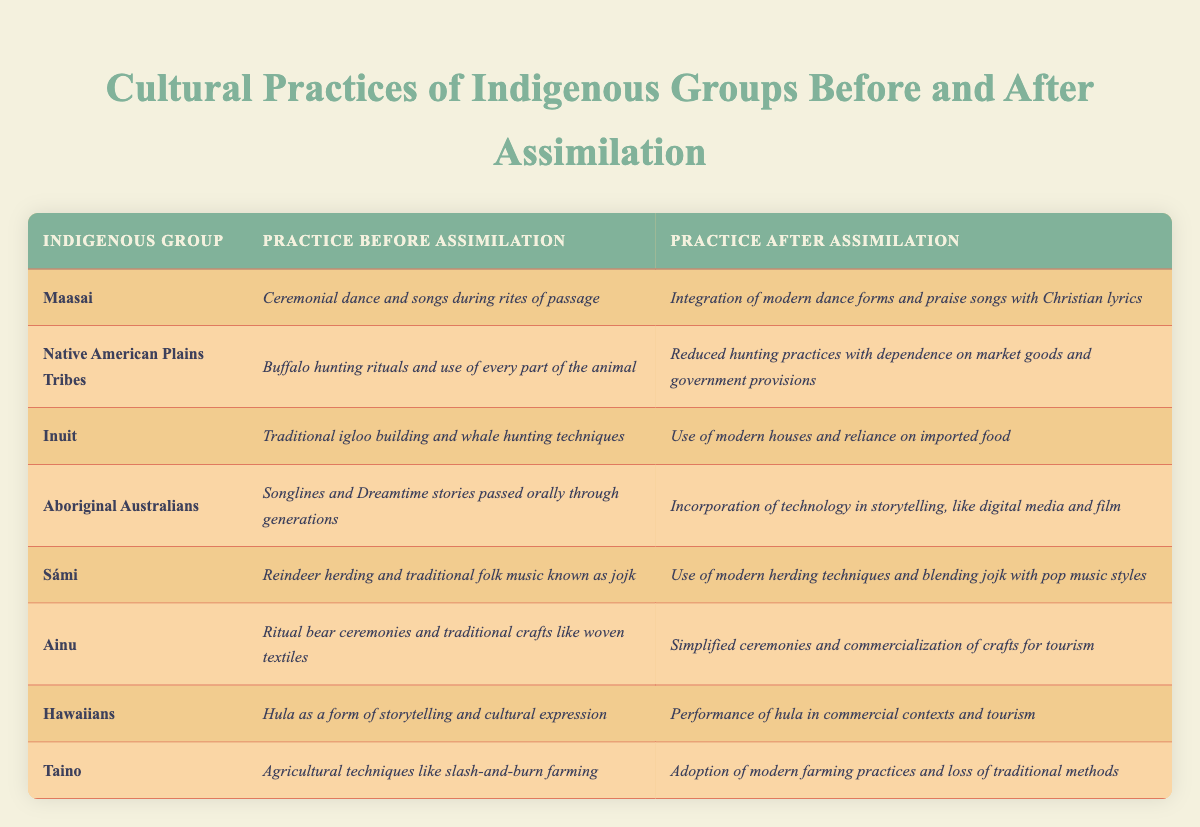What cultural practice did the Maasai integrate after assimilation? The table indicates that after assimilation, the Maasai integrated modern dance forms and praise songs with Christian lyrics, which is clearly stated in the corresponding row.
Answer: Integration of modern dance forms and praise songs with Christian lyrics What traditional practice did the Inuit lose after assimilation? By examining the table, we find that the Inuit traditionally practiced igloo building and whale hunting techniques, which were replaced by the use of modern houses and reliance on imported food after assimilation.
Answer: Traditional igloo building and whale hunting techniques Did Ainu rituals become more simplified or complex after assimilation? The row for Ainu indicates that their rituals became simplified after assimilation, as stated in the second column under "Practice After Assimilation."
Answer: Simplified Which group practiced buffalo hunting rituals before assimilation? The table specifies that the Native American Plains Tribes practiced buffalo hunting rituals before assimilation, as reflected in the first column.
Answer: Native American Plains Tribes How many indigenous groups mentioned in the table maintained some aspect of their traditional practices after assimilation? By reviewing each row, we identify that several groups incorporated elements of their traditional practices into modern contexts, such as the blending of jojk with pop music by the Sámi and the digital media use by Aboriginal Australians. Therefore, 5 groups mentioned some aspects remained.
Answer: 5 Is it true that all groups completely lost their agricultural practices after assimilation? The table indicates that the Taino adopted modern farming practices, which implies a shift rather than a complete loss, while other groups did not primarily focus on agriculture, so the statement is false.
Answer: False Among the cultures listed, which underwent a shift towards commercial contexts in their cultural expressions? Observing the table, both the Hawaiians and Ainu moved towards commercial contexts, as indicated by their practices of hula and crafts being incorporated into tourism.
Answer: Hawaiians and Ainu Which cultural practice was most significantly altered according to the information after assimilation? The Inuit's original traditional practice of building igloos and hunting whales was completely transformed to using modern houses and relying on imported food, signifying a significant alteration.
Answer: Inuit traditional practices What was the main change for the practice of storytelling among Aboriginal Australians after assimilation? The table highlights that Aboriginal Australians shifted from oral storytelling traditions to incorporating technology like digital media and film in their narratives, representing a fundamental change in how stories are shared.
Answer: Incorporation of technology in storytelling 